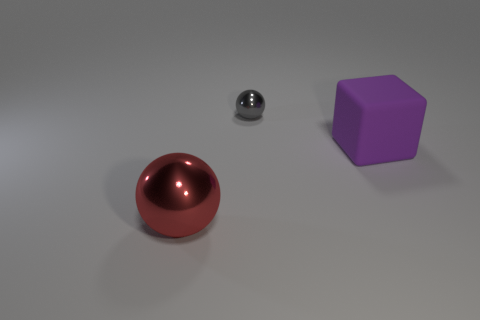If this were a scene from a story, what mood would it convey? The image could convey a sense of simplicity and order, possibly suggesting a calm or tranquil mood. The clean background and the neat arrangement of objects contribute to a feeling of serenity or isolation within the narrative. 